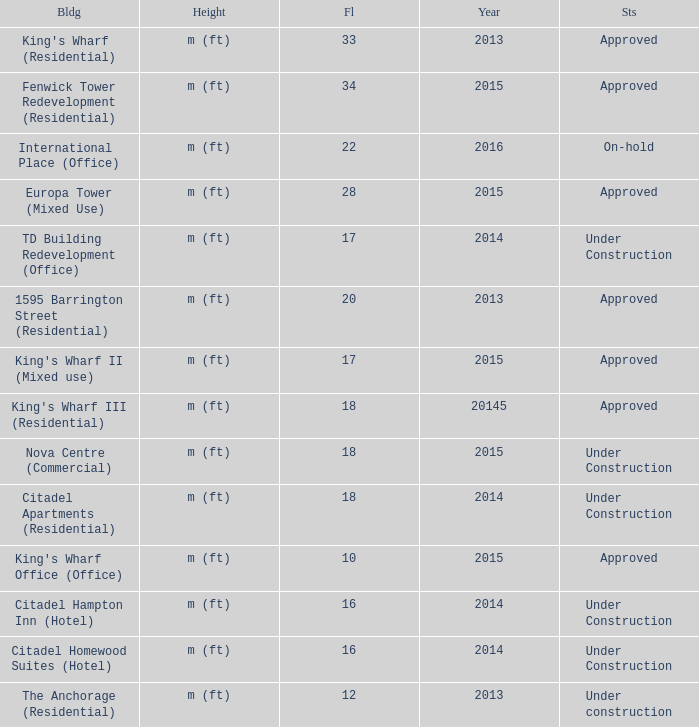What building shows 2013 and has more than 20 floors? King's Wharf (Residential). 